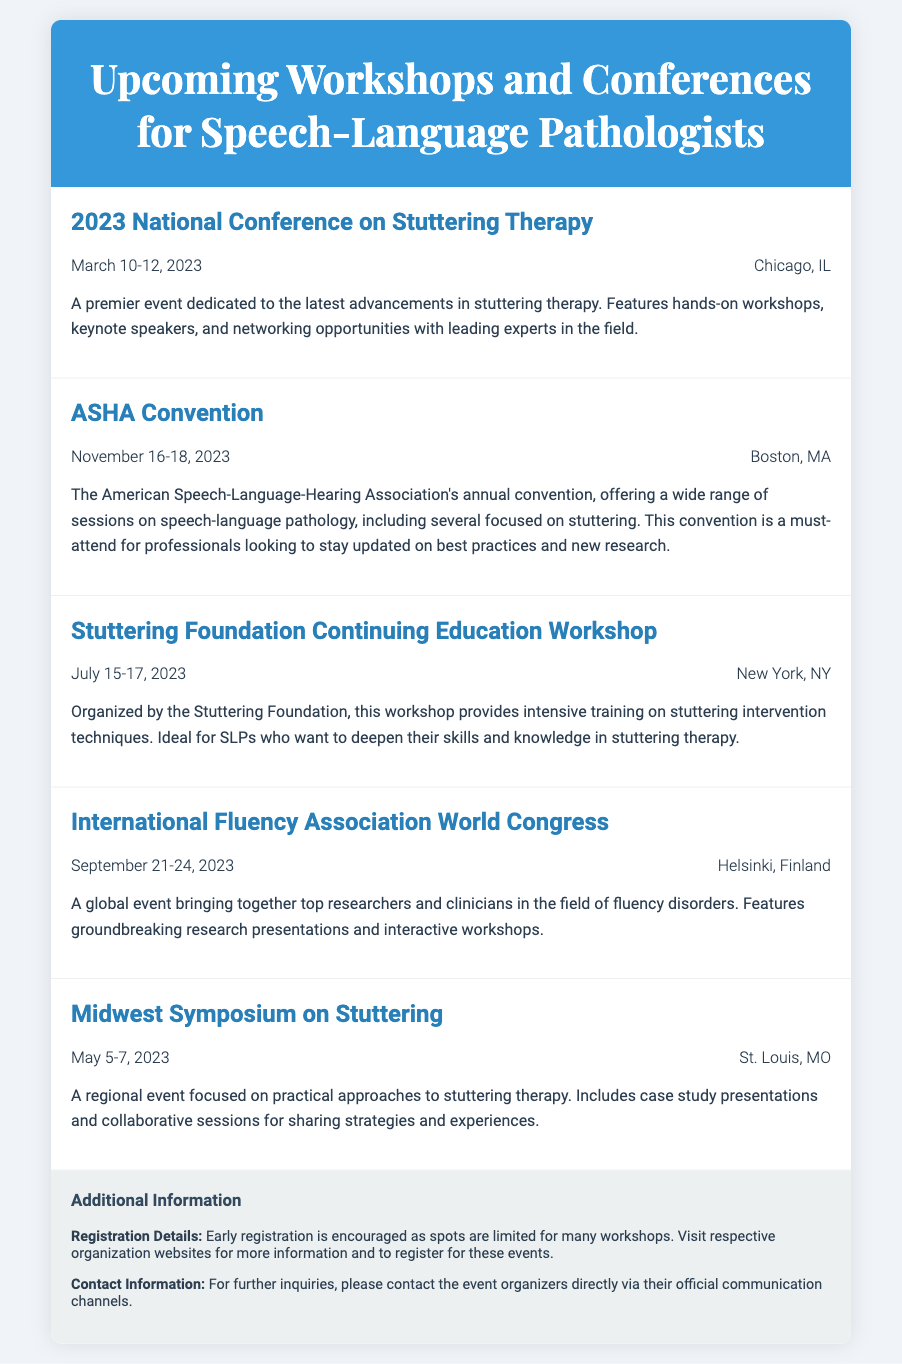what is the title of the first conference listed? The first conference listed in the document has the title "2023 National Conference on Stuttering Therapy."
Answer: 2023 National Conference on Stuttering Therapy when is the ASHA Convention scheduled? The document provides the date for the ASHA Convention as November 16-18, 2023.
Answer: November 16-18, 2023 where will the International Fluency Association World Congress be held? The location for the International Fluency Association World Congress is stated as Helsinki, Finland.
Answer: Helsinki, Finland how many days does the Stuttering Foundation Continuing Education Workshop last? The document specifies that the Stuttering Foundation Continuing Education Workshop lasts for three days from July 15-17, 2023.
Answer: 3 days what type of sessions does the Midwest Symposium on Stuttering include? The document mentions that the Midwest Symposium on Stuttering includes case study presentations and collaborative sessions.
Answer: case study presentations and collaborative sessions are early registrations recommended for the workshops? The additional information section explicitly advises early registration as spots are limited for many workshops.
Answer: Yes what is the primary focus of the events listed in the document? The document collectively emphasizes the advancement and therapy of speech-related disorders, especially stuttering.
Answer: stuttering therapy how often does the ASHA Convention occur? The ASHA Convention is described as an annual event in the document.
Answer: annual 